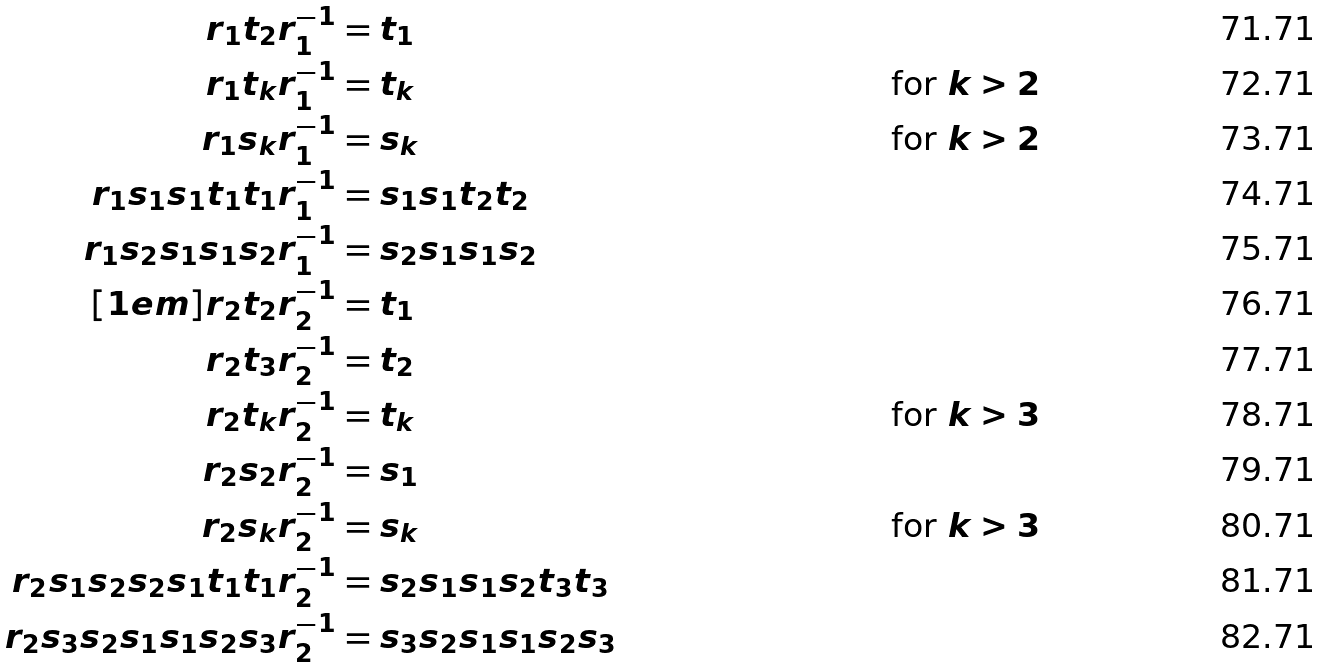<formula> <loc_0><loc_0><loc_500><loc_500>r _ { 1 } t _ { 2 } r _ { 1 } ^ { - 1 } & = t _ { 1 } \\ r _ { 1 } t _ { k } r _ { 1 } ^ { - 1 } & = t _ { k } & \text {for } k > 2 \\ r _ { 1 } s _ { k } r _ { 1 } ^ { - 1 } & = s _ { k } & \text {for } k > 2 \\ r _ { 1 } s _ { 1 } s _ { 1 } t _ { 1 } t _ { 1 } r _ { 1 } ^ { - 1 } & = s _ { 1 } s _ { 1 } t _ { 2 } t _ { 2 } & \\ r _ { 1 } s _ { 2 } s _ { 1 } s _ { 1 } s _ { 2 } r _ { 1 } ^ { - 1 } & = s _ { 2 } s _ { 1 } s _ { 1 } s _ { 2 } & \\ [ 1 e m ] r _ { 2 } t _ { 2 } r _ { 2 } ^ { - 1 } & = t _ { 1 } & \\ r _ { 2 } t _ { 3 } r _ { 2 } ^ { - 1 } & = t _ { 2 } & \\ r _ { 2 } t _ { k } r _ { 2 } ^ { - 1 } & = t _ { k } & \text {for } k > 3 \\ r _ { 2 } s _ { 2 } r _ { 2 } ^ { - 1 } & = s _ { 1 } & \\ r _ { 2 } s _ { k } r _ { 2 } ^ { - 1 } & = s _ { k } & \text {for } k > 3 \\ r _ { 2 } s _ { 1 } s _ { 2 } s _ { 2 } s _ { 1 } t _ { 1 } t _ { 1 } r _ { 2 } ^ { - 1 } & = s _ { 2 } s _ { 1 } s _ { 1 } s _ { 2 } t _ { 3 } t _ { 3 } & \\ r _ { 2 } s _ { 3 } s _ { 2 } s _ { 1 } s _ { 1 } s _ { 2 } s _ { 3 } r _ { 2 } ^ { - 1 } & = s _ { 3 } s _ { 2 } s _ { 1 } s _ { 1 } s _ { 2 } s _ { 3 } &</formula> 